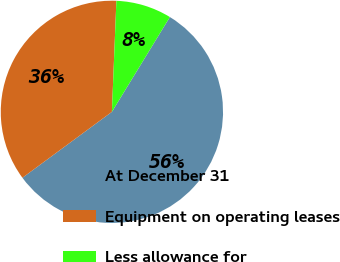<chart> <loc_0><loc_0><loc_500><loc_500><pie_chart><fcel>At December 31<fcel>Equipment on operating leases<fcel>Less allowance for<nl><fcel>56.16%<fcel>35.75%<fcel>8.09%<nl></chart> 